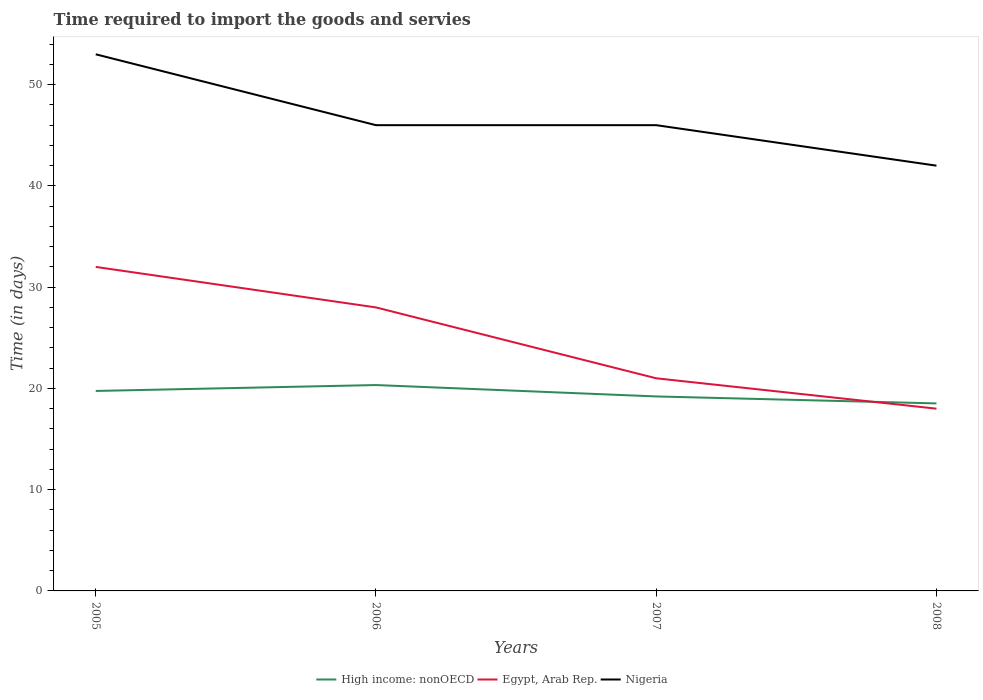Is the number of lines equal to the number of legend labels?
Ensure brevity in your answer.  Yes. Across all years, what is the maximum number of days required to import the goods and services in Egypt, Arab Rep.?
Ensure brevity in your answer.  18. What is the total number of days required to import the goods and services in High income: nonOECD in the graph?
Your answer should be very brief. 0.54. What is the difference between the highest and the second highest number of days required to import the goods and services in Egypt, Arab Rep.?
Make the answer very short. 14. What is the difference between the highest and the lowest number of days required to import the goods and services in High income: nonOECD?
Provide a succinct answer. 2. Is the number of days required to import the goods and services in Nigeria strictly greater than the number of days required to import the goods and services in High income: nonOECD over the years?
Offer a very short reply. No. How many lines are there?
Give a very brief answer. 3. Are the values on the major ticks of Y-axis written in scientific E-notation?
Give a very brief answer. No. What is the title of the graph?
Your response must be concise. Time required to import the goods and servies. Does "Kuwait" appear as one of the legend labels in the graph?
Offer a terse response. No. What is the label or title of the X-axis?
Provide a succinct answer. Years. What is the label or title of the Y-axis?
Your answer should be very brief. Time (in days). What is the Time (in days) in High income: nonOECD in 2005?
Your answer should be compact. 19.75. What is the Time (in days) of Egypt, Arab Rep. in 2005?
Provide a short and direct response. 32. What is the Time (in days) in Nigeria in 2005?
Your response must be concise. 53. What is the Time (in days) of High income: nonOECD in 2006?
Give a very brief answer. 20.33. What is the Time (in days) in High income: nonOECD in 2007?
Give a very brief answer. 19.21. What is the Time (in days) of Egypt, Arab Rep. in 2007?
Offer a very short reply. 21. What is the Time (in days) of High income: nonOECD in 2008?
Keep it short and to the point. 18.52. Across all years, what is the maximum Time (in days) in High income: nonOECD?
Offer a terse response. 20.33. Across all years, what is the maximum Time (in days) of Egypt, Arab Rep.?
Your answer should be very brief. 32. Across all years, what is the maximum Time (in days) of Nigeria?
Offer a very short reply. 53. Across all years, what is the minimum Time (in days) in High income: nonOECD?
Offer a very short reply. 18.52. Across all years, what is the minimum Time (in days) of Egypt, Arab Rep.?
Provide a succinct answer. 18. Across all years, what is the minimum Time (in days) of Nigeria?
Offer a terse response. 42. What is the total Time (in days) in High income: nonOECD in the graph?
Keep it short and to the point. 77.81. What is the total Time (in days) in Nigeria in the graph?
Provide a short and direct response. 187. What is the difference between the Time (in days) of High income: nonOECD in 2005 and that in 2006?
Ensure brevity in your answer.  -0.58. What is the difference between the Time (in days) in Egypt, Arab Rep. in 2005 and that in 2006?
Keep it short and to the point. 4. What is the difference between the Time (in days) in Nigeria in 2005 and that in 2006?
Your answer should be very brief. 7. What is the difference between the Time (in days) of High income: nonOECD in 2005 and that in 2007?
Give a very brief answer. 0.54. What is the difference between the Time (in days) in Egypt, Arab Rep. in 2005 and that in 2007?
Offer a terse response. 11. What is the difference between the Time (in days) in Nigeria in 2005 and that in 2007?
Your response must be concise. 7. What is the difference between the Time (in days) of High income: nonOECD in 2005 and that in 2008?
Your answer should be very brief. 1.23. What is the difference between the Time (in days) in Egypt, Arab Rep. in 2005 and that in 2008?
Ensure brevity in your answer.  14. What is the difference between the Time (in days) of Nigeria in 2006 and that in 2007?
Your answer should be very brief. 0. What is the difference between the Time (in days) of High income: nonOECD in 2006 and that in 2008?
Offer a terse response. 1.81. What is the difference between the Time (in days) in High income: nonOECD in 2007 and that in 2008?
Provide a short and direct response. 0.69. What is the difference between the Time (in days) in Nigeria in 2007 and that in 2008?
Your answer should be compact. 4. What is the difference between the Time (in days) in High income: nonOECD in 2005 and the Time (in days) in Egypt, Arab Rep. in 2006?
Keep it short and to the point. -8.25. What is the difference between the Time (in days) of High income: nonOECD in 2005 and the Time (in days) of Nigeria in 2006?
Make the answer very short. -26.25. What is the difference between the Time (in days) in Egypt, Arab Rep. in 2005 and the Time (in days) in Nigeria in 2006?
Offer a very short reply. -14. What is the difference between the Time (in days) in High income: nonOECD in 2005 and the Time (in days) in Egypt, Arab Rep. in 2007?
Provide a succinct answer. -1.25. What is the difference between the Time (in days) in High income: nonOECD in 2005 and the Time (in days) in Nigeria in 2007?
Give a very brief answer. -26.25. What is the difference between the Time (in days) in Egypt, Arab Rep. in 2005 and the Time (in days) in Nigeria in 2007?
Ensure brevity in your answer.  -14. What is the difference between the Time (in days) in High income: nonOECD in 2005 and the Time (in days) in Nigeria in 2008?
Offer a very short reply. -22.25. What is the difference between the Time (in days) in High income: nonOECD in 2006 and the Time (in days) in Egypt, Arab Rep. in 2007?
Make the answer very short. -0.67. What is the difference between the Time (in days) of High income: nonOECD in 2006 and the Time (in days) of Nigeria in 2007?
Provide a short and direct response. -25.67. What is the difference between the Time (in days) in Egypt, Arab Rep. in 2006 and the Time (in days) in Nigeria in 2007?
Your answer should be compact. -18. What is the difference between the Time (in days) of High income: nonOECD in 2006 and the Time (in days) of Egypt, Arab Rep. in 2008?
Provide a short and direct response. 2.33. What is the difference between the Time (in days) in High income: nonOECD in 2006 and the Time (in days) in Nigeria in 2008?
Offer a very short reply. -21.67. What is the difference between the Time (in days) of High income: nonOECD in 2007 and the Time (in days) of Egypt, Arab Rep. in 2008?
Provide a short and direct response. 1.21. What is the difference between the Time (in days) of High income: nonOECD in 2007 and the Time (in days) of Nigeria in 2008?
Your response must be concise. -22.79. What is the difference between the Time (in days) of Egypt, Arab Rep. in 2007 and the Time (in days) of Nigeria in 2008?
Provide a succinct answer. -21. What is the average Time (in days) in High income: nonOECD per year?
Your response must be concise. 19.45. What is the average Time (in days) in Egypt, Arab Rep. per year?
Make the answer very short. 24.75. What is the average Time (in days) of Nigeria per year?
Make the answer very short. 46.75. In the year 2005, what is the difference between the Time (in days) of High income: nonOECD and Time (in days) of Egypt, Arab Rep.?
Offer a very short reply. -12.25. In the year 2005, what is the difference between the Time (in days) of High income: nonOECD and Time (in days) of Nigeria?
Offer a very short reply. -33.25. In the year 2005, what is the difference between the Time (in days) of Egypt, Arab Rep. and Time (in days) of Nigeria?
Keep it short and to the point. -21. In the year 2006, what is the difference between the Time (in days) in High income: nonOECD and Time (in days) in Egypt, Arab Rep.?
Give a very brief answer. -7.67. In the year 2006, what is the difference between the Time (in days) of High income: nonOECD and Time (in days) of Nigeria?
Ensure brevity in your answer.  -25.67. In the year 2007, what is the difference between the Time (in days) of High income: nonOECD and Time (in days) of Egypt, Arab Rep.?
Offer a terse response. -1.79. In the year 2007, what is the difference between the Time (in days) in High income: nonOECD and Time (in days) in Nigeria?
Make the answer very short. -26.79. In the year 2008, what is the difference between the Time (in days) of High income: nonOECD and Time (in days) of Egypt, Arab Rep.?
Your response must be concise. 0.52. In the year 2008, what is the difference between the Time (in days) in High income: nonOECD and Time (in days) in Nigeria?
Your answer should be very brief. -23.48. What is the ratio of the Time (in days) in High income: nonOECD in 2005 to that in 2006?
Your response must be concise. 0.97. What is the ratio of the Time (in days) in Nigeria in 2005 to that in 2006?
Your response must be concise. 1.15. What is the ratio of the Time (in days) of High income: nonOECD in 2005 to that in 2007?
Make the answer very short. 1.03. What is the ratio of the Time (in days) in Egypt, Arab Rep. in 2005 to that in 2007?
Your answer should be compact. 1.52. What is the ratio of the Time (in days) of Nigeria in 2005 to that in 2007?
Offer a terse response. 1.15. What is the ratio of the Time (in days) of High income: nonOECD in 2005 to that in 2008?
Offer a terse response. 1.07. What is the ratio of the Time (in days) in Egypt, Arab Rep. in 2005 to that in 2008?
Offer a terse response. 1.78. What is the ratio of the Time (in days) in Nigeria in 2005 to that in 2008?
Give a very brief answer. 1.26. What is the ratio of the Time (in days) of High income: nonOECD in 2006 to that in 2007?
Provide a succinct answer. 1.06. What is the ratio of the Time (in days) of High income: nonOECD in 2006 to that in 2008?
Provide a succinct answer. 1.1. What is the ratio of the Time (in days) of Egypt, Arab Rep. in 2006 to that in 2008?
Provide a short and direct response. 1.56. What is the ratio of the Time (in days) of Nigeria in 2006 to that in 2008?
Your response must be concise. 1.1. What is the ratio of the Time (in days) of High income: nonOECD in 2007 to that in 2008?
Provide a short and direct response. 1.04. What is the ratio of the Time (in days) of Nigeria in 2007 to that in 2008?
Provide a short and direct response. 1.1. What is the difference between the highest and the second highest Time (in days) in High income: nonOECD?
Provide a succinct answer. 0.58. What is the difference between the highest and the lowest Time (in days) of High income: nonOECD?
Offer a terse response. 1.81. What is the difference between the highest and the lowest Time (in days) of Egypt, Arab Rep.?
Your answer should be compact. 14. 